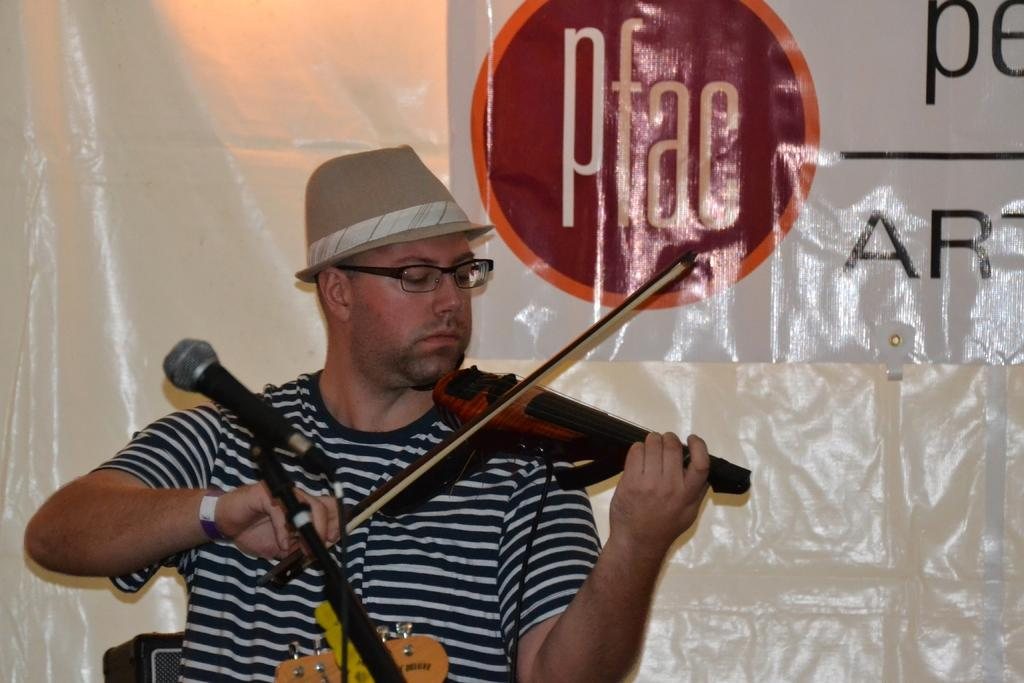What is the man in the image doing? The man is playing a violin in the image. What object is present in the image that might be used for amplifying sound? There is a microphone in the image. Can you see any police officers in the image? No, there are no police officers present in the image. What type of kitty can be seen playing with the violin in the image? There is no kitty present in the image, and therefore no such activity can be observed. 